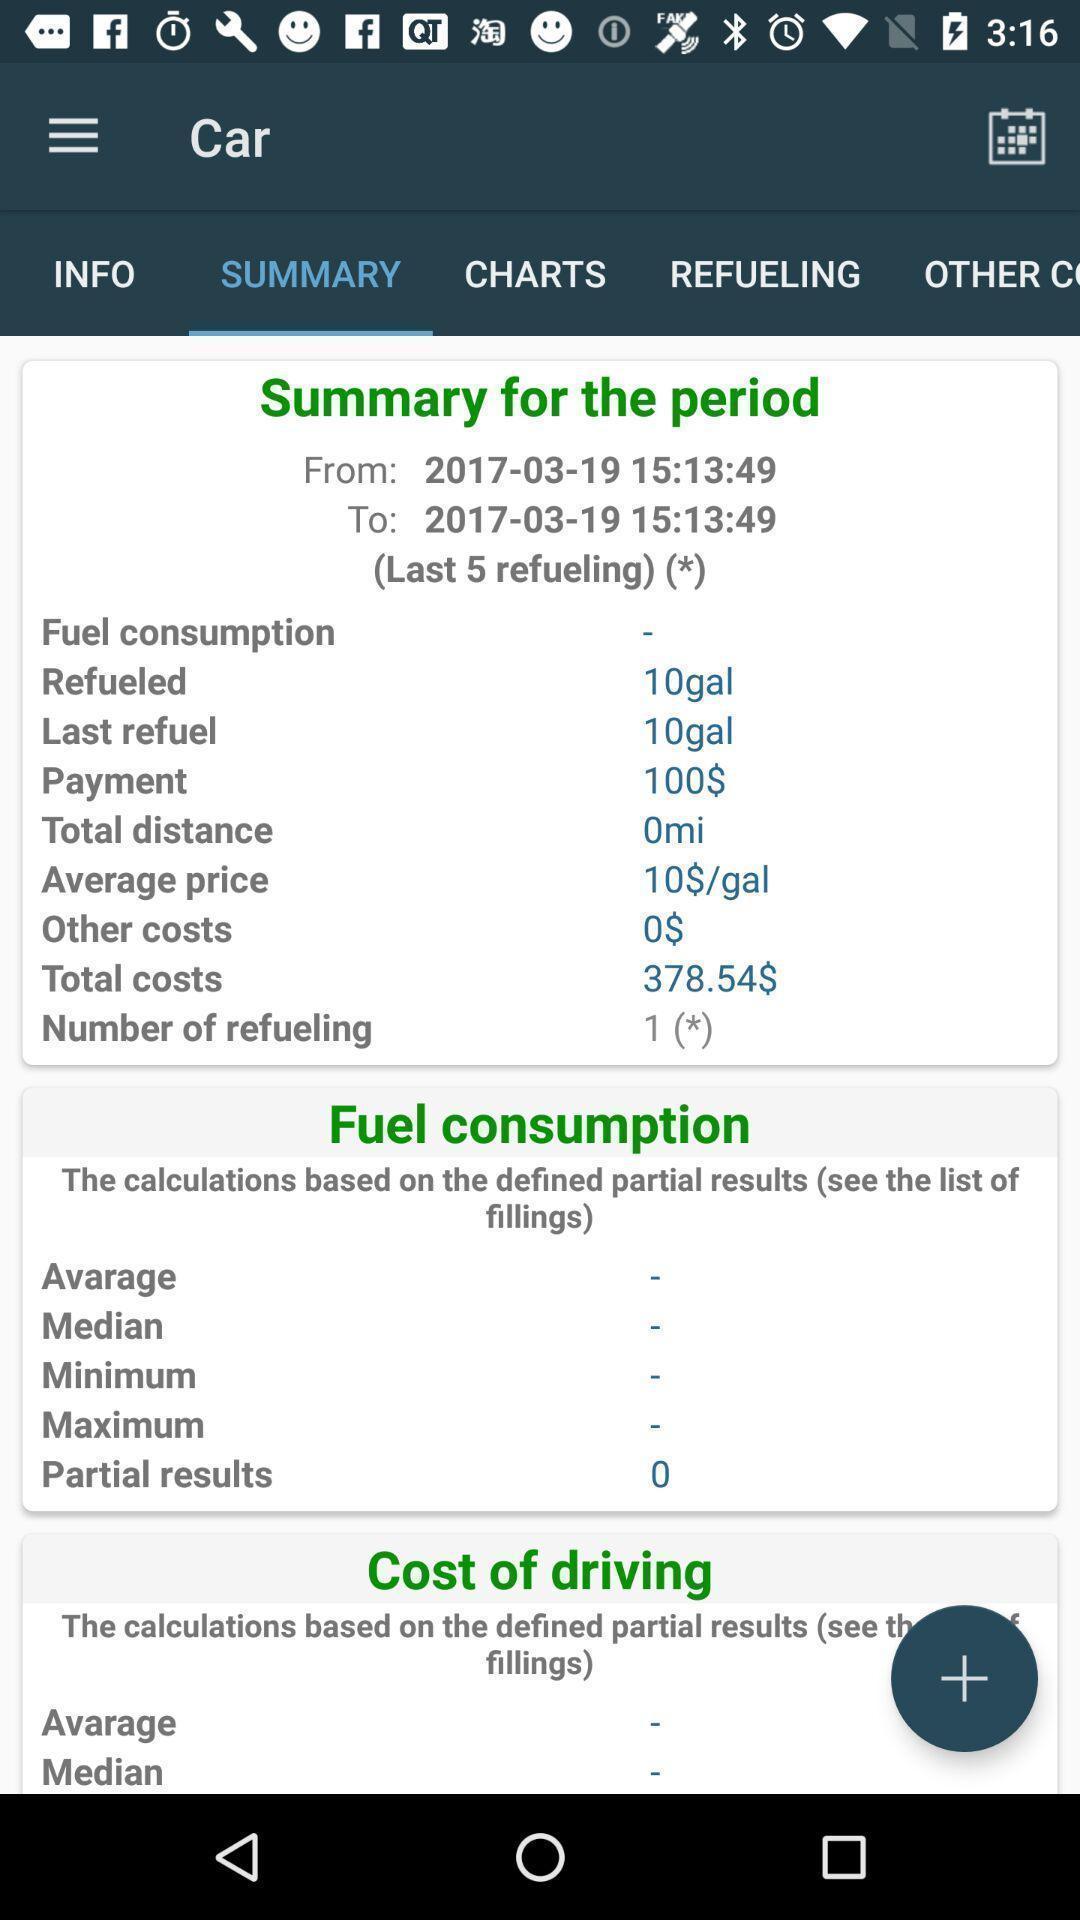Provide a textual representation of this image. Page showing summary of a vehicle fuel consumption. 